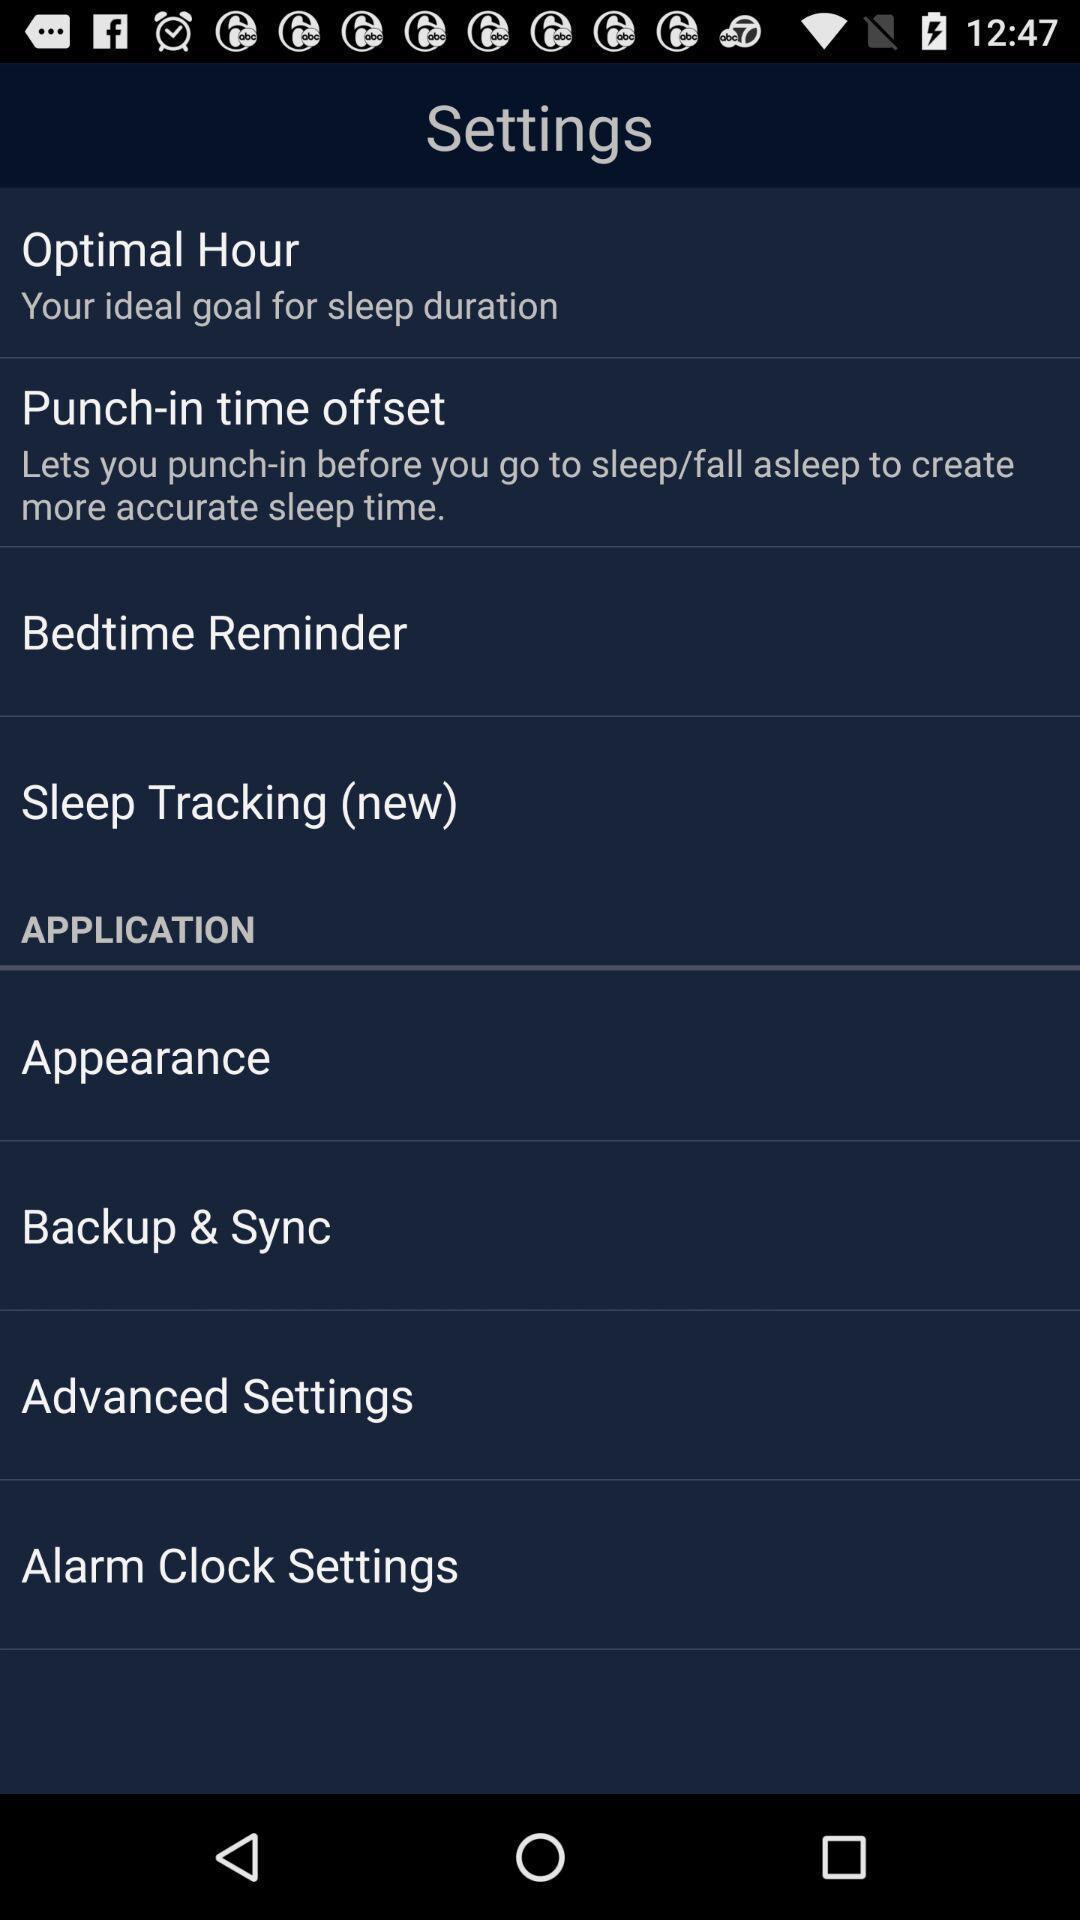Summarize the information in this screenshot. Settings page. 